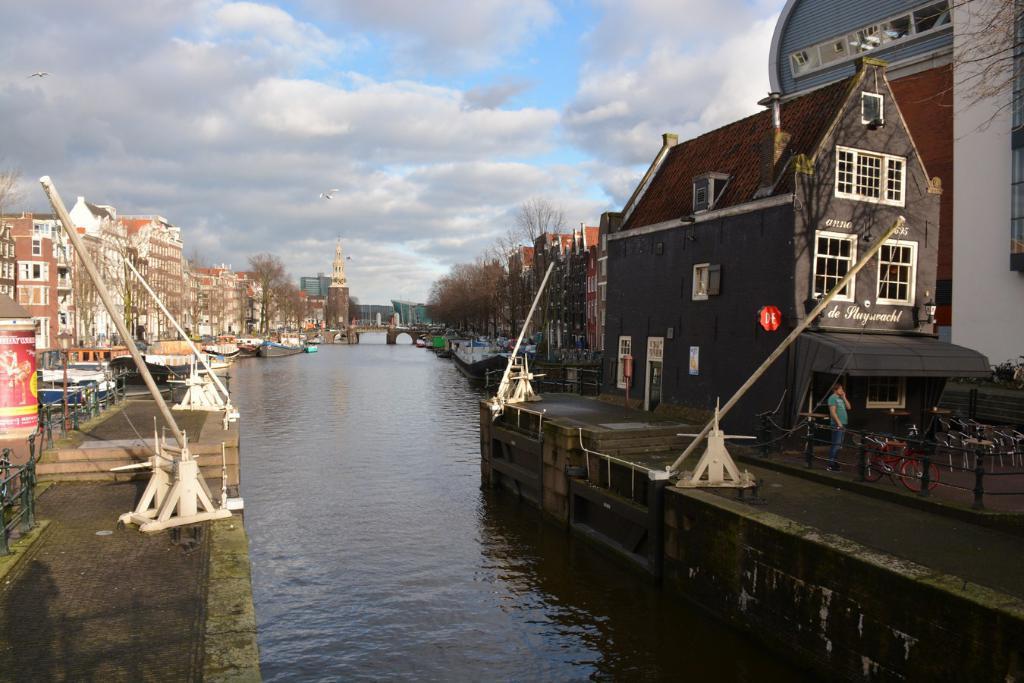Describe this image in one or two sentences. In this picture I can see boats on the water, there is a bridge, there is a person standing, there are iron grilles, there are buildings, trees, and in the background there is the sky. 